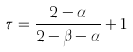<formula> <loc_0><loc_0><loc_500><loc_500>\tau = \frac { 2 - \alpha } { 2 - \beta - \alpha } + 1</formula> 